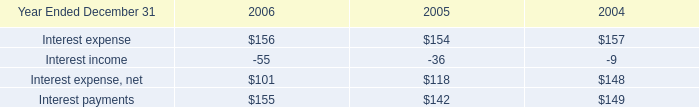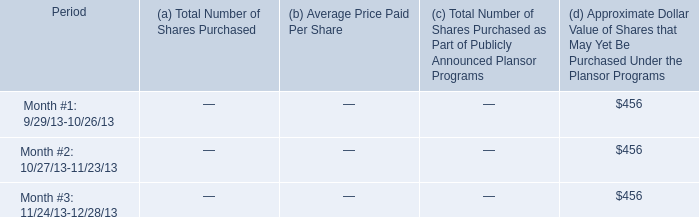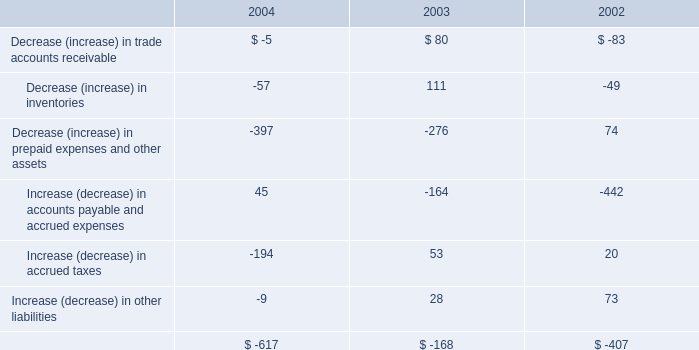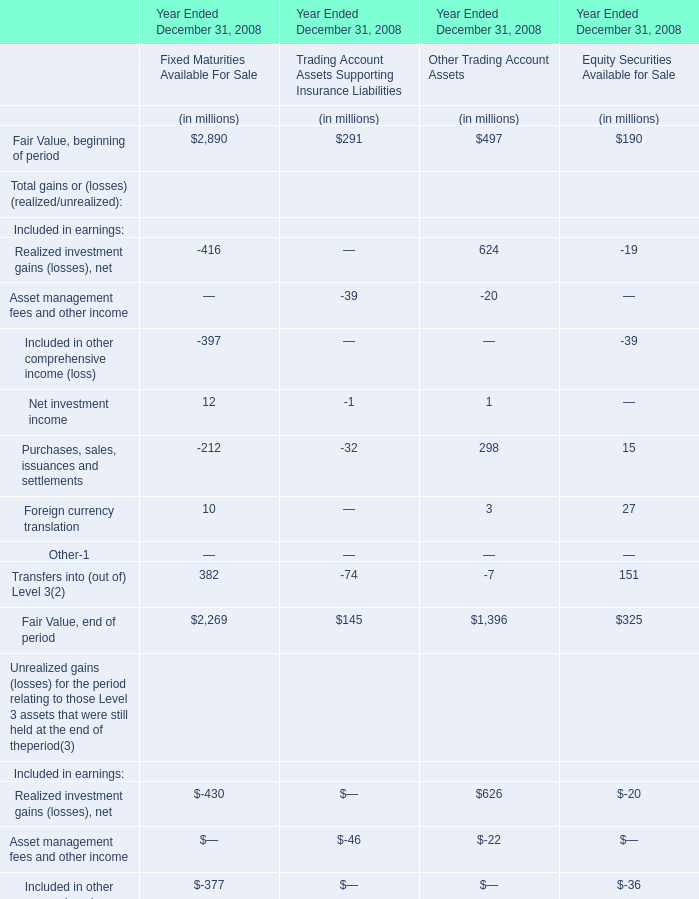Which section is Fixed Maturities Available For Sale the most? 
Answer: Fixed Maturities Available For Sale. 